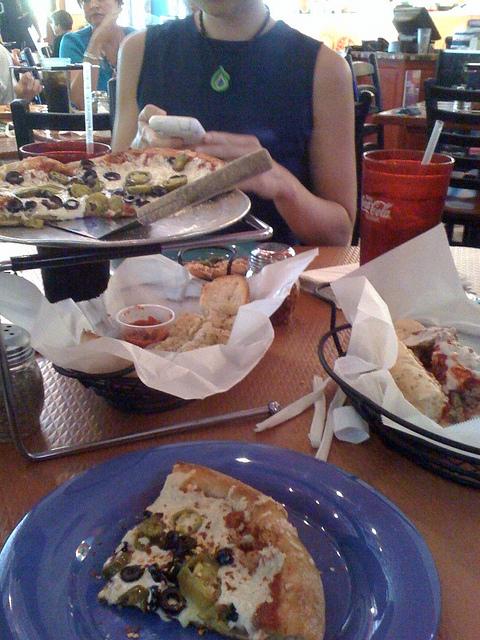What does the person appear to be doing? The individual is engaged in the act of eating, specifically holding up what seems to be a garlic breadstick or bread, over a plate with a partially eaten pizza slice on it. Their posture indicates a moment of casual dining, perhaps in the midst of a meal with friends or family. 